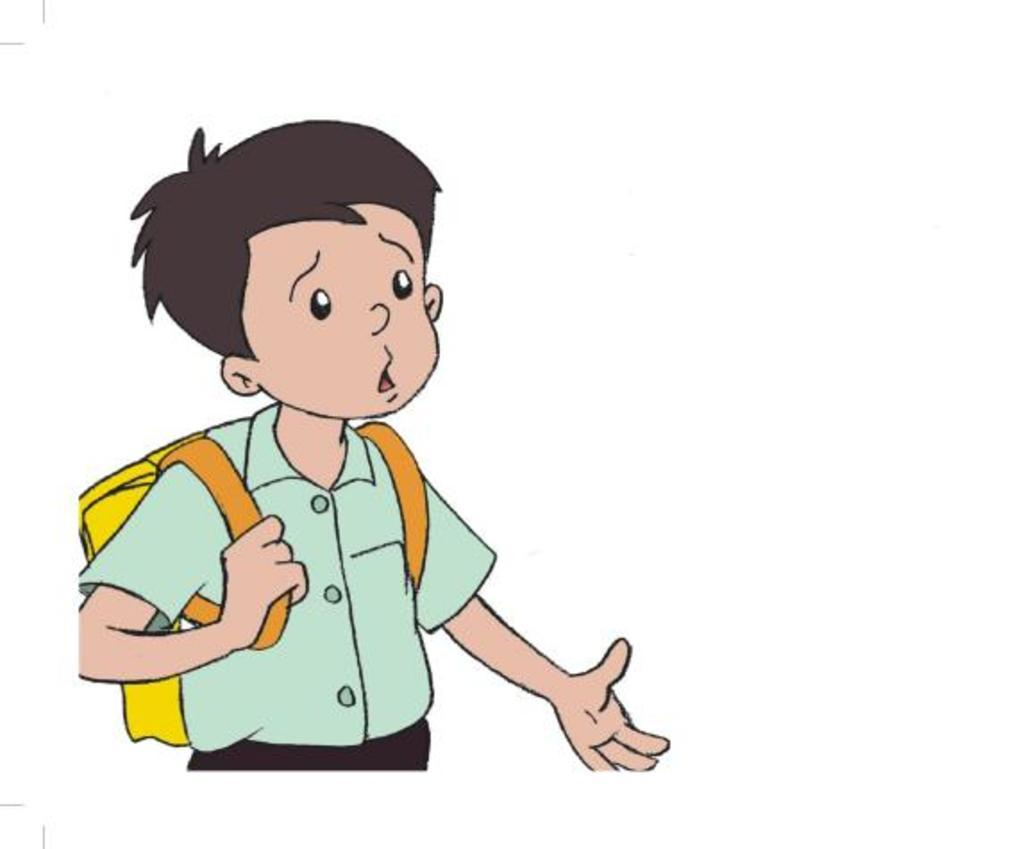What type of image is depicted in the picture? There is a cartoon image of a boy in the picture. What is the boy wearing in the image? The boy is wearing a school bag in the image. What color is the background of the image? The background of the image is white. Can you see any mountains in the background of the image? There are no mountains visible in the image; the background is white. What type of pets are present in the image? There are no pets present in the image; it features a cartoon image of a boy with a school bag. 